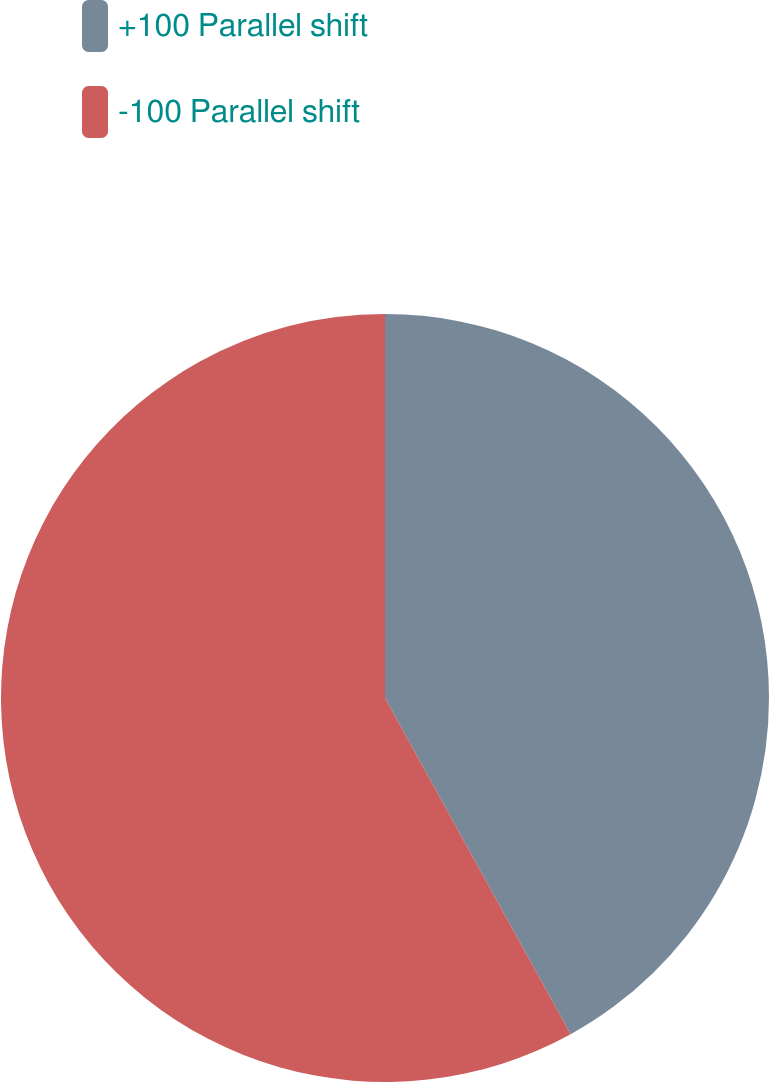Convert chart to OTSL. <chart><loc_0><loc_0><loc_500><loc_500><pie_chart><fcel>+100 Parallel shift<fcel>-100 Parallel shift<nl><fcel>41.97%<fcel>58.03%<nl></chart> 